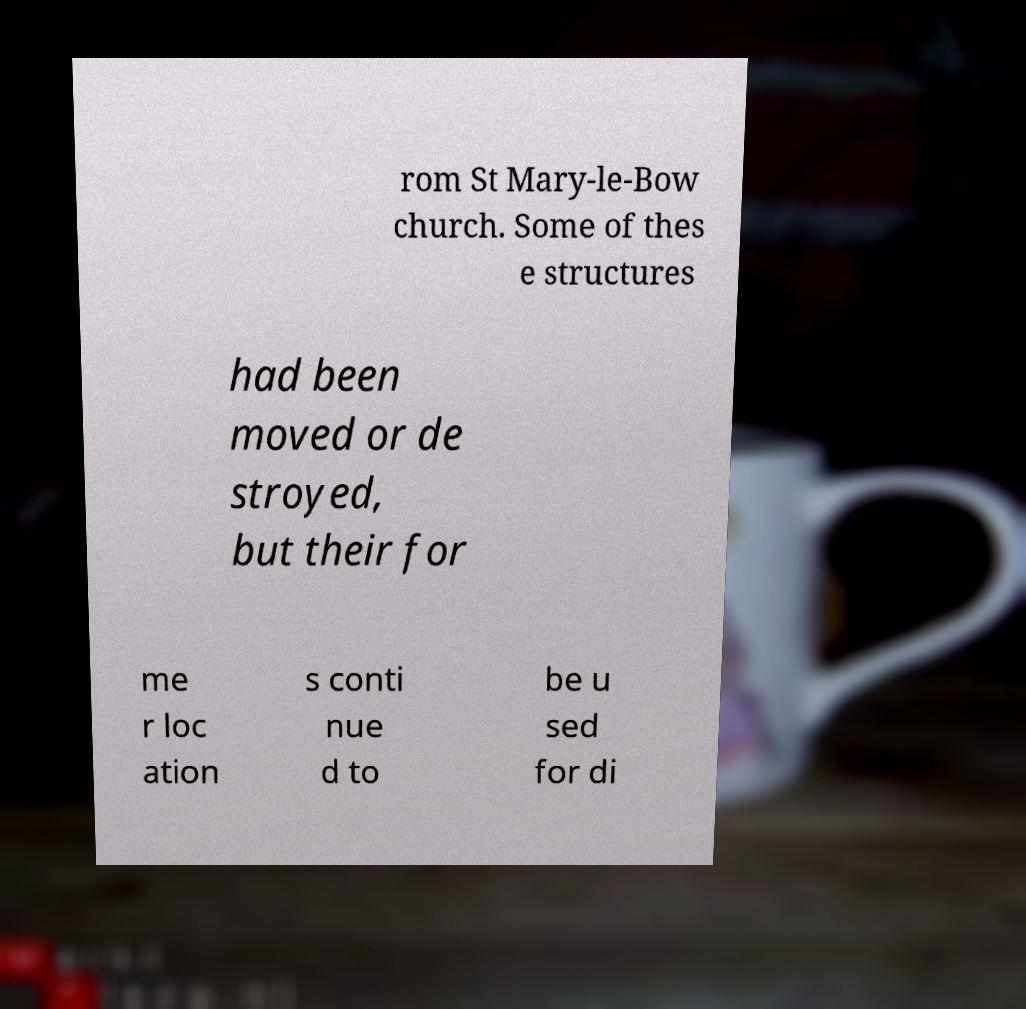There's text embedded in this image that I need extracted. Can you transcribe it verbatim? rom St Mary-le-Bow church. Some of thes e structures had been moved or de stroyed, but their for me r loc ation s conti nue d to be u sed for di 